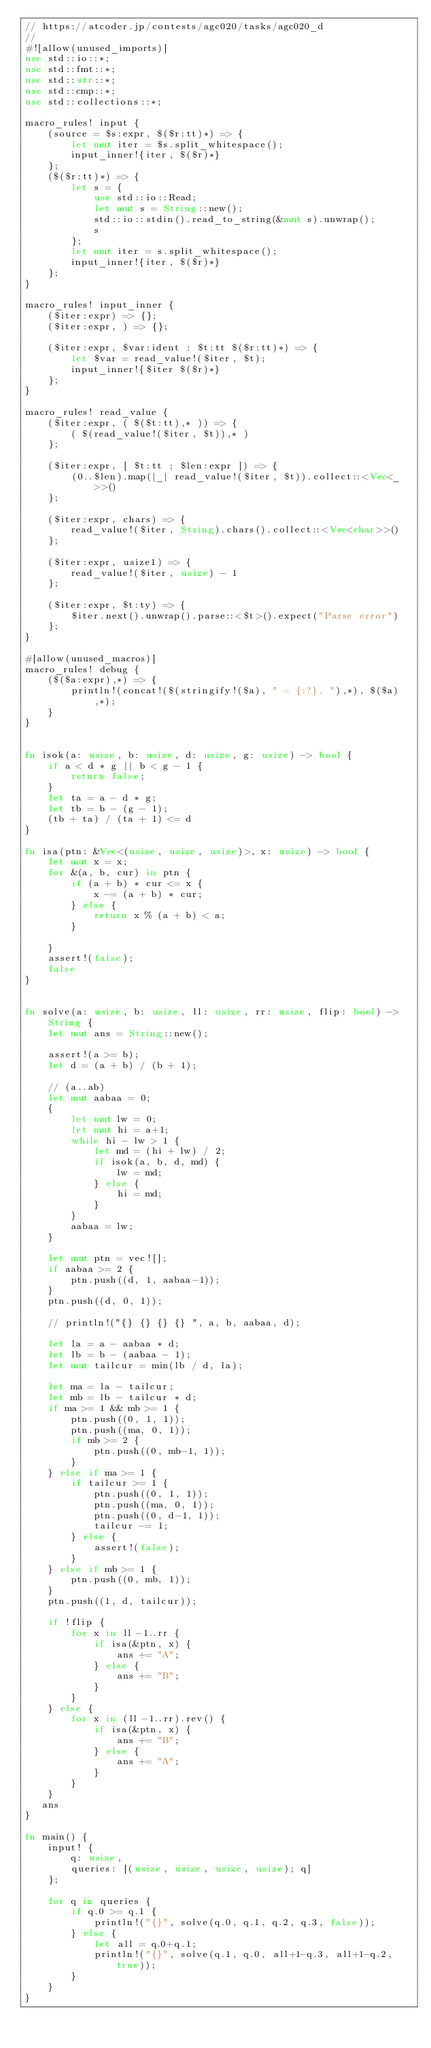<code> <loc_0><loc_0><loc_500><loc_500><_Rust_>// https://atcoder.jp/contests/agc020/tasks/agc020_d
//
#![allow(unused_imports)]
use std::io::*;
use std::fmt::*;
use std::str::*;
use std::cmp::*;
use std::collections::*;

macro_rules! input {
    (source = $s:expr, $($r:tt)*) => {
        let mut iter = $s.split_whitespace();
        input_inner!{iter, $($r)*}
    };
    ($($r:tt)*) => {
        let s = {
            use std::io::Read;
            let mut s = String::new();
            std::io::stdin().read_to_string(&mut s).unwrap();
            s
        };
        let mut iter = s.split_whitespace();
        input_inner!{iter, $($r)*}
    };
}

macro_rules! input_inner {
    ($iter:expr) => {};
    ($iter:expr, ) => {};

    ($iter:expr, $var:ident : $t:tt $($r:tt)*) => {
        let $var = read_value!($iter, $t);
        input_inner!{$iter $($r)*}
    };
}

macro_rules! read_value {
    ($iter:expr, ( $($t:tt),* )) => {
        ( $(read_value!($iter, $t)),* )
    };

    ($iter:expr, [ $t:tt ; $len:expr ]) => {
        (0..$len).map(|_| read_value!($iter, $t)).collect::<Vec<_>>()
    };

    ($iter:expr, chars) => {
        read_value!($iter, String).chars().collect::<Vec<char>>()
    };

    ($iter:expr, usize1) => {
        read_value!($iter, usize) - 1
    };

    ($iter:expr, $t:ty) => {
        $iter.next().unwrap().parse::<$t>().expect("Parse error")
    };
}

#[allow(unused_macros)]
macro_rules! debug {
    ($($a:expr),*) => {
        println!(concat!($(stringify!($a), " = {:?}, "),*), $($a),*);
    }
}


fn isok(a: usize, b: usize, d: usize, g: usize) -> bool {
    if a < d * g || b < g - 1 {
        return false;
    }
    let ta = a - d * g;
    let tb = b - (g - 1);
    (tb + ta) / (ta + 1) <= d
}

fn isa(ptn: &Vec<(usize, usize, usize)>, x: usize) -> bool {
    let mut x = x;
    for &(a, b, cur) in ptn {
        if (a + b) * cur <= x {
            x -= (a + b) * cur;
        } else {
            return x % (a + b) < a;
        }

    }
    assert!(false);
    false
}


fn solve(a: usize, b: usize, ll: usize, rr: usize, flip: bool) -> String {
    let mut ans = String::new();

    assert!(a >= b);
    let d = (a + b) / (b + 1);

    // (a..ab)
    let mut aabaa = 0;
    {
        let mut lw = 0;
        let mut hi = a+1;
        while hi - lw > 1 {
            let md = (hi + lw) / 2;
            if isok(a, b, d, md) {
                lw = md;
            } else {
                hi = md;
            }
        }
        aabaa = lw;
    }

    let mut ptn = vec![];
    if aabaa >= 2 {
        ptn.push((d, 1, aabaa-1));
    }
    ptn.push((d, 0, 1));

    // println!("{} {} {} {} ", a, b, aabaa, d);

    let la = a - aabaa * d;
    let lb = b - (aabaa - 1);
    let mut tailcur = min(lb / d, la);

    let ma = la - tailcur;
    let mb = lb - tailcur * d;
    if ma >= 1 && mb >= 1 {
        ptn.push((0, 1, 1));
        ptn.push((ma, 0, 1));
        if mb >= 2 {
            ptn.push((0, mb-1, 1));
        }
    } else if ma >= 1 {
        if tailcur >= 1 {
            ptn.push((0, 1, 1));
            ptn.push((ma, 0, 1));
            ptn.push((0, d-1, 1));
            tailcur -= 1;
        } else {
            assert!(false);
        }
    } else if mb >= 1 {
        ptn.push((0, mb, 1));
    }
    ptn.push((1, d, tailcur));

    if !flip {
        for x in ll-1..rr {
            if isa(&ptn, x) {
                ans += "A";
            } else {
                ans += "B";
            }
        }
    } else {
        for x in (ll-1..rr).rev() {
            if isa(&ptn, x) {
                ans += "B";
            } else {
                ans += "A";
            }
        }
    }
   ans
}

fn main() {
    input! {
        q: usize,
        queries: [(usize, usize, usize, usize); q]
    };

    for q in queries {
        if q.0 >= q.1 {
            println!("{}", solve(q.0, q.1, q.2, q.3, false));
        } else {
            let all = q.0+q.1;
            println!("{}", solve(q.1, q.0, all+1-q.3, all+1-q.2, true));
        }
    }
}
</code> 